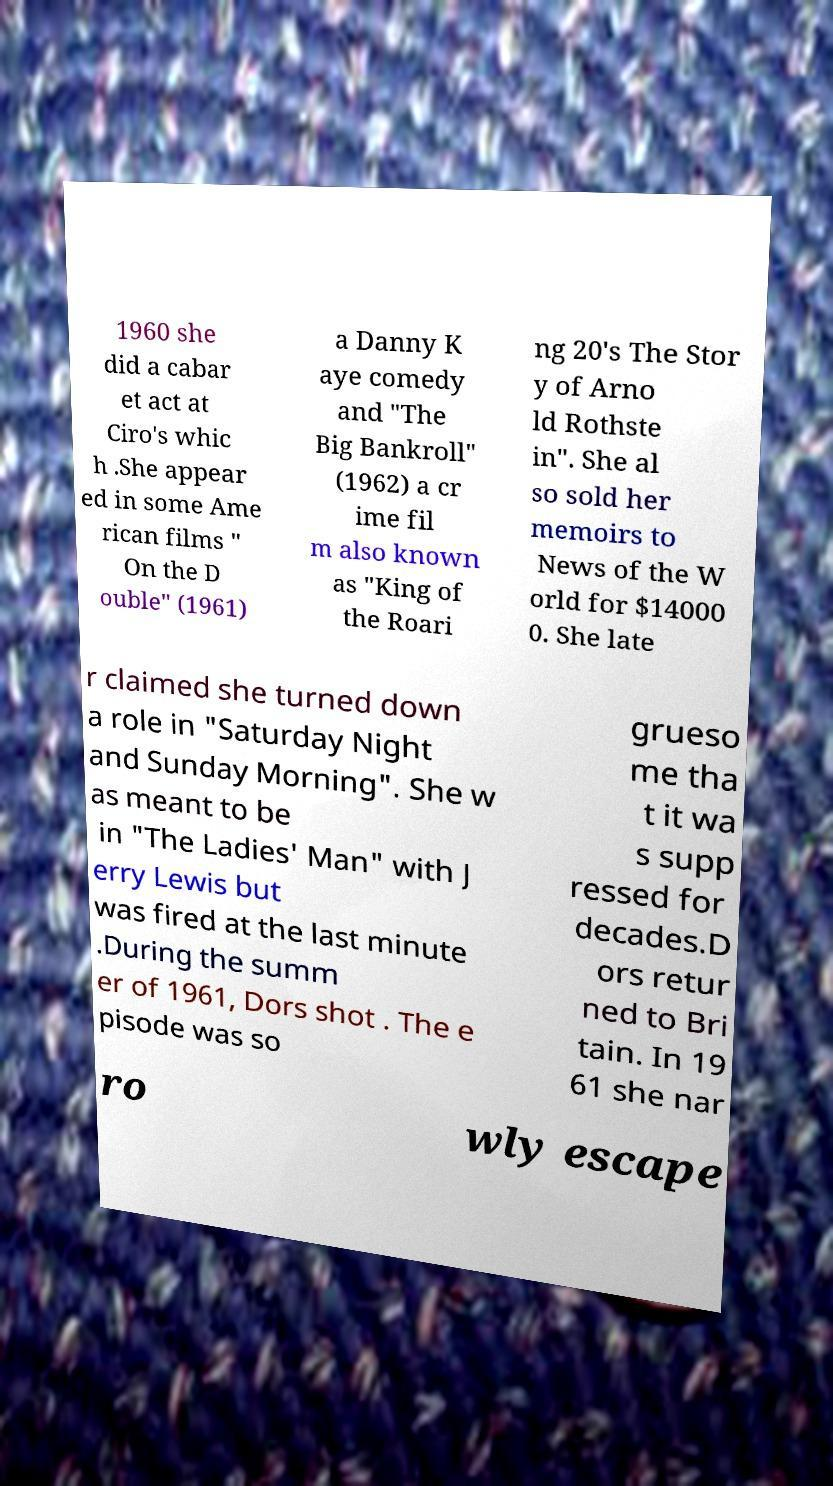Please identify and transcribe the text found in this image. 1960 she did a cabar et act at Ciro's whic h .She appear ed in some Ame rican films " On the D ouble" (1961) a Danny K aye comedy and "The Big Bankroll" (1962) a cr ime fil m also known as "King of the Roari ng 20's The Stor y of Arno ld Rothste in". She al so sold her memoirs to News of the W orld for $14000 0. She late r claimed she turned down a role in "Saturday Night and Sunday Morning". She w as meant to be in "The Ladies' Man" with J erry Lewis but was fired at the last minute .During the summ er of 1961, Dors shot . The e pisode was so grueso me tha t it wa s supp ressed for decades.D ors retur ned to Bri tain. In 19 61 she nar ro wly escape 